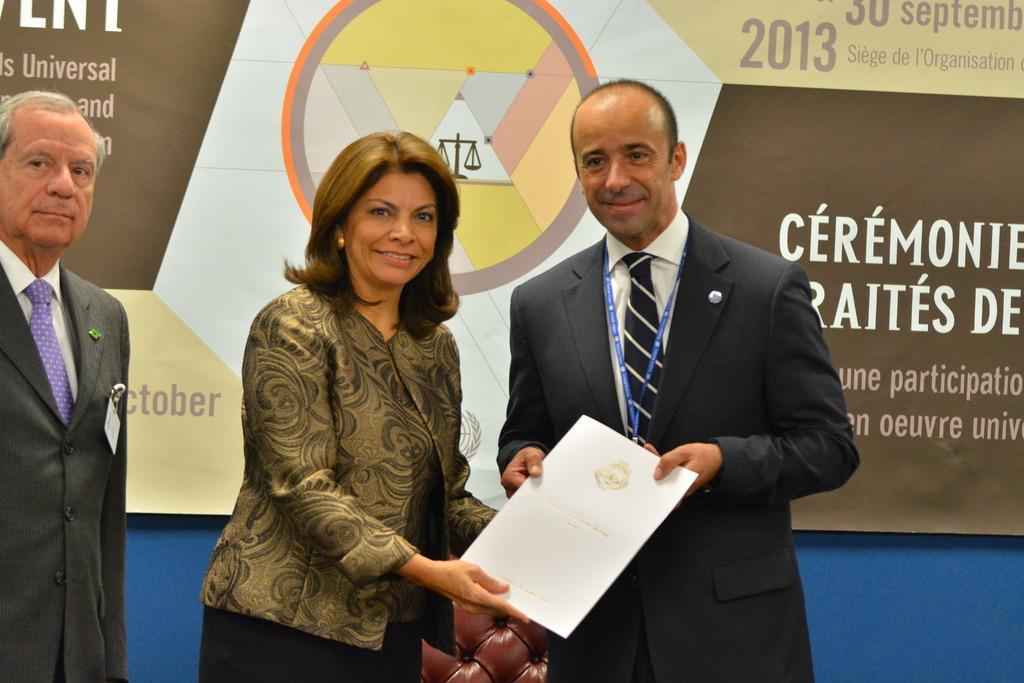Please provide a concise description of this image. In this image we can see three people standing, two of them are holding a paper looks like a certificate, behind them there is a chair and a board with some text. 